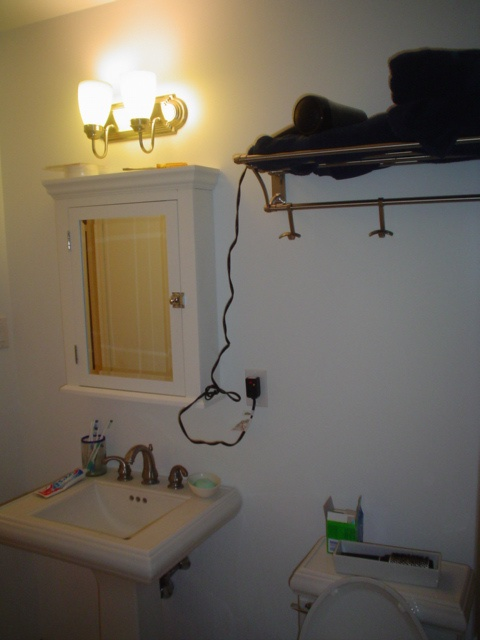Describe the objects in this image and their specific colors. I can see sink in olive, gray, and black tones, toilet in olive, black, and purple tones, hair drier in olive, black, and gray tones, cup in olive, black, and gray tones, and toothbrush in olive, gray, black, and darkgreen tones in this image. 